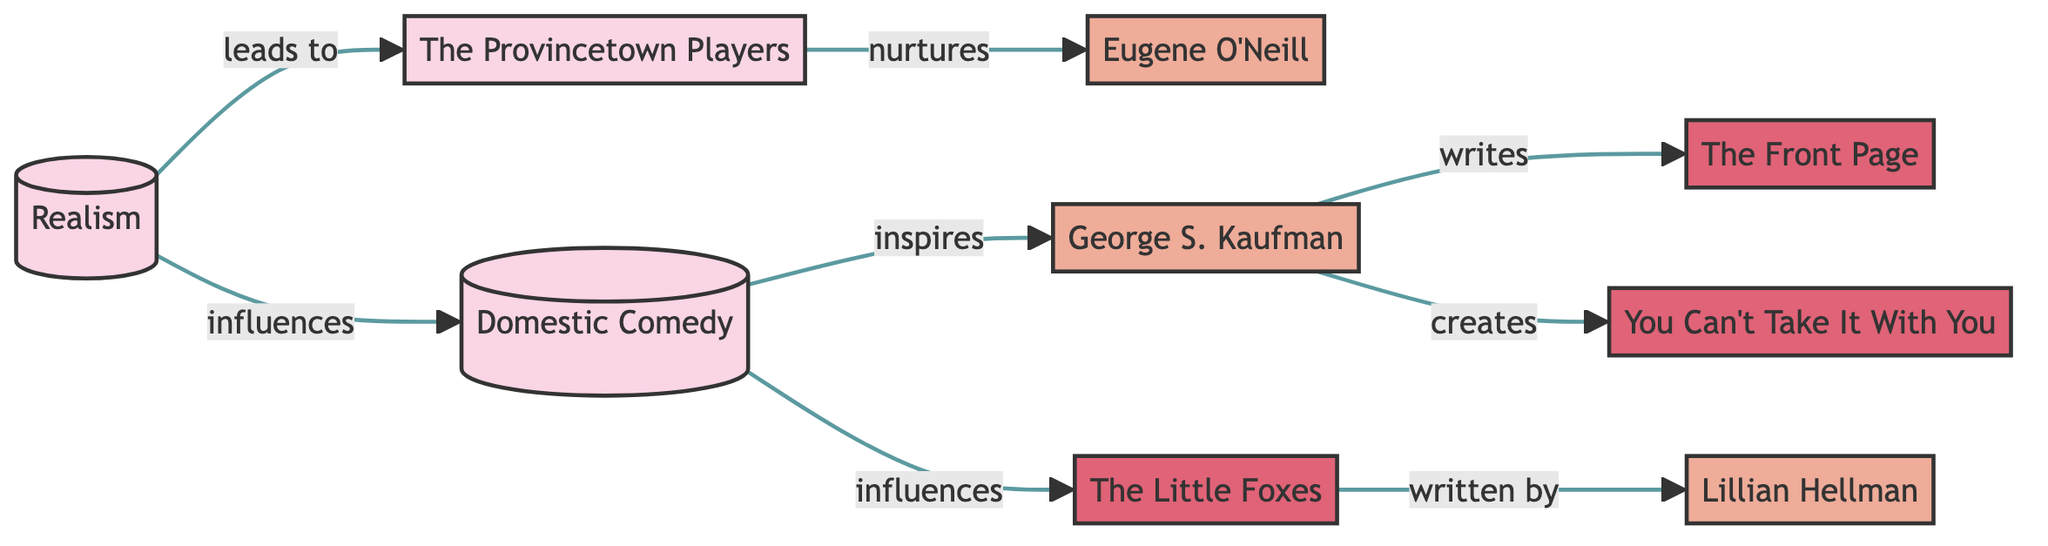What is the total number of nodes in the diagram? There are 9 nodes represented in the diagram, which include movements, plays, and playwrights.
Answer: 9 Which movement influences Domestic Comedy? The directed edge from Realism to Domestic Comedy indicates that Realism influences Domestic Comedy.
Answer: Realism Who wrote "The Front Page"? The directed edge from George S. Kaufman to The Front Page indicates that George S. Kaufman is the writer of this play.
Answer: George S. Kaufman How many plays are inspired by Domestic Comedy? There are three plays directly associated with Domestic Comedy: The Front Page, You Can't Take It With You, and The Little Foxes, where The Little Foxes is written by Lillian Hellman and the others by George S. Kaufman.
Answer: 3 Which playwright is nurtured by The Provincetown Players? The directed edge from The Provincetown Players to Eugene O'Neill indicates that Eugene O'Neill is nurtured by this movement.
Answer: Eugene O'Neill What is the relationship between Domestic Comedy and The Little Foxes? The directed edge from Domestic Comedy to The Little Foxes shows that Domestic Comedy influences The Little Foxes, which is also revealed by the edge pointing from The Little Foxes to Lillian Hellman as the author.
Answer: influences How many edges are there in the graph? Counting the relationships designed in the diagram, there are 8 edges that connect the different nodes.
Answer: 8 Which playwright created "You Can't Take It With You"? The directed edge from George S. Kaufman to You Can't Take It With You indicates that George S. Kaufman created this play.
Answer: George S. Kaufman Which node represents a theater movement that leads to specific playwrights and plays? The edge connections suggest that Realism leads to both Domestic Comedy and The Provincetown Players, both of which influence known playwrights and plays.
Answer: Realism 